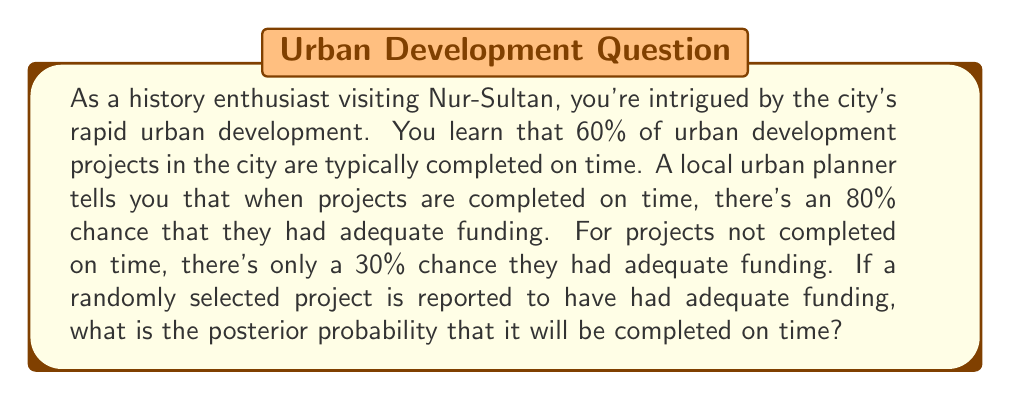Can you answer this question? Let's approach this problem using Bayes' theorem. We'll define the following events:

$T$: The project is completed on time
$F$: The project has adequate funding

We're given the following probabilities:

$P(T) = 0.60$ (prior probability of on-time completion)
$P(F|T) = 0.80$ (probability of adequate funding given on-time completion)
$P(F|\neg T) = 0.30$ (probability of adequate funding given not on-time completion)

We want to find $P(T|F)$, the posterior probability of on-time completion given adequate funding.

Bayes' theorem states:

$$P(T|F) = \frac{P(F|T) \cdot P(T)}{P(F)}$$

We need to calculate $P(F)$ using the law of total probability:

$$P(F) = P(F|T) \cdot P(T) + P(F|\neg T) \cdot P(\neg T)$$

$P(\neg T) = 1 - P(T) = 1 - 0.60 = 0.40$

Now, let's calculate $P(F)$:

$$\begin{align*}
P(F) &= 0.80 \cdot 0.60 + 0.30 \cdot 0.40 \\
&= 0.48 + 0.12 \\
&= 0.60
\end{align*}$$

Now we can apply Bayes' theorem:

$$\begin{align*}
P(T|F) &= \frac{P(F|T) \cdot P(T)}{P(F)} \\
&= \frac{0.80 \cdot 0.60}{0.60} \\
&= \frac{0.48}{0.60} \\
&= 0.80
\end{align*}$$
Answer: The posterior probability that a project with adequate funding will be completed on time is 0.80 or 80%. 